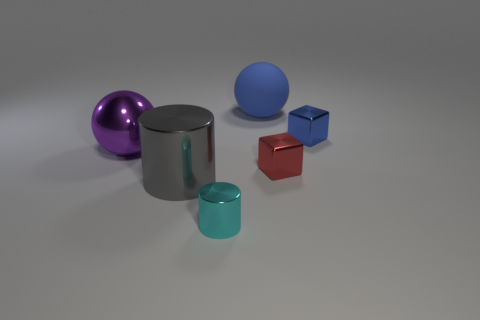Are there more big gray metal things that are in front of the big gray object than tiny red objects? After examining the image, there are indeed more sizable gray metal objects positioned closer to the forefront when compared to the smaller red object. Specifically, we can identify two large gray items, likely metallic, in front of the large central gray object, compared to a single small red cube. 